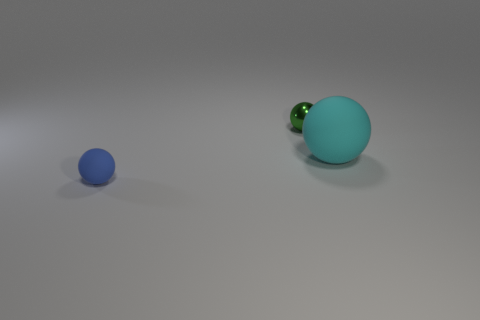Can you tell me what the color of the larger ball is? Certainly! The larger ball appears to be a shade of turquoise. 